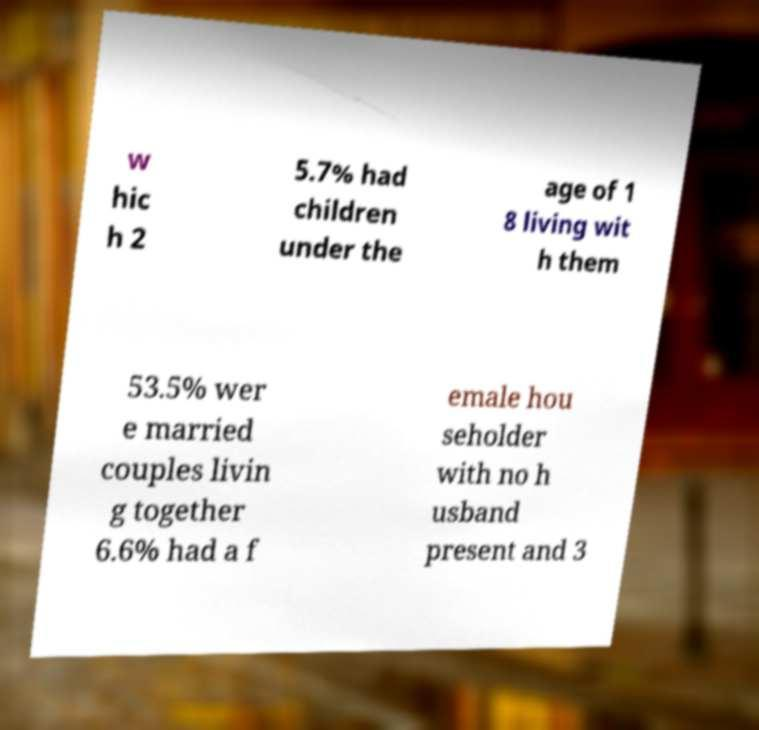Could you assist in decoding the text presented in this image and type it out clearly? w hic h 2 5.7% had children under the age of 1 8 living wit h them 53.5% wer e married couples livin g together 6.6% had a f emale hou seholder with no h usband present and 3 